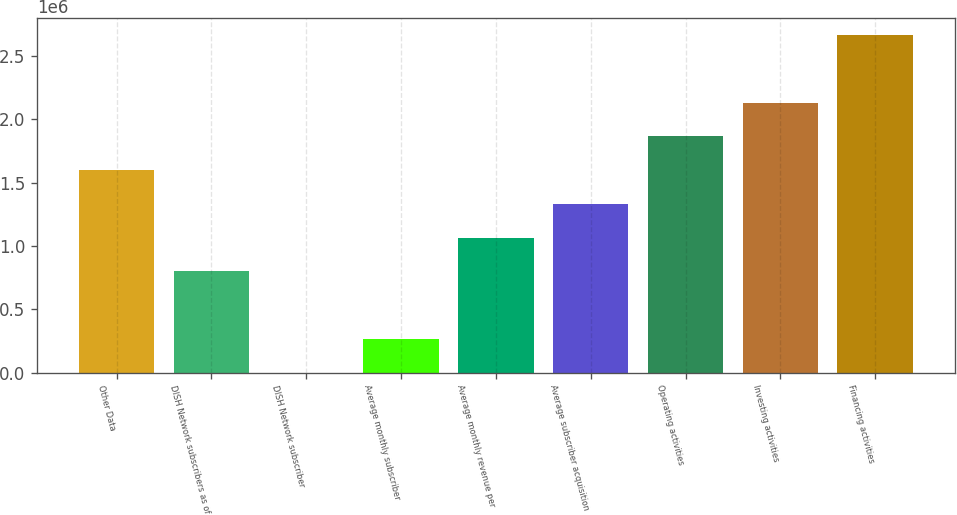Convert chart to OTSL. <chart><loc_0><loc_0><loc_500><loc_500><bar_chart><fcel>Other Data<fcel>DISH Network subscribers as of<fcel>DISH Network subscriber<fcel>Average monthly subscriber<fcel>Average monthly revenue per<fcel>Average subscriber acquisition<fcel>Operating activities<fcel>Investing activities<fcel>Financing activities<nl><fcel>1.59961e+06<fcel>799808<fcel>1.48<fcel>266604<fcel>1.06641e+06<fcel>1.33301e+06<fcel>1.86622e+06<fcel>2.13282e+06<fcel>2.66602e+06<nl></chart> 